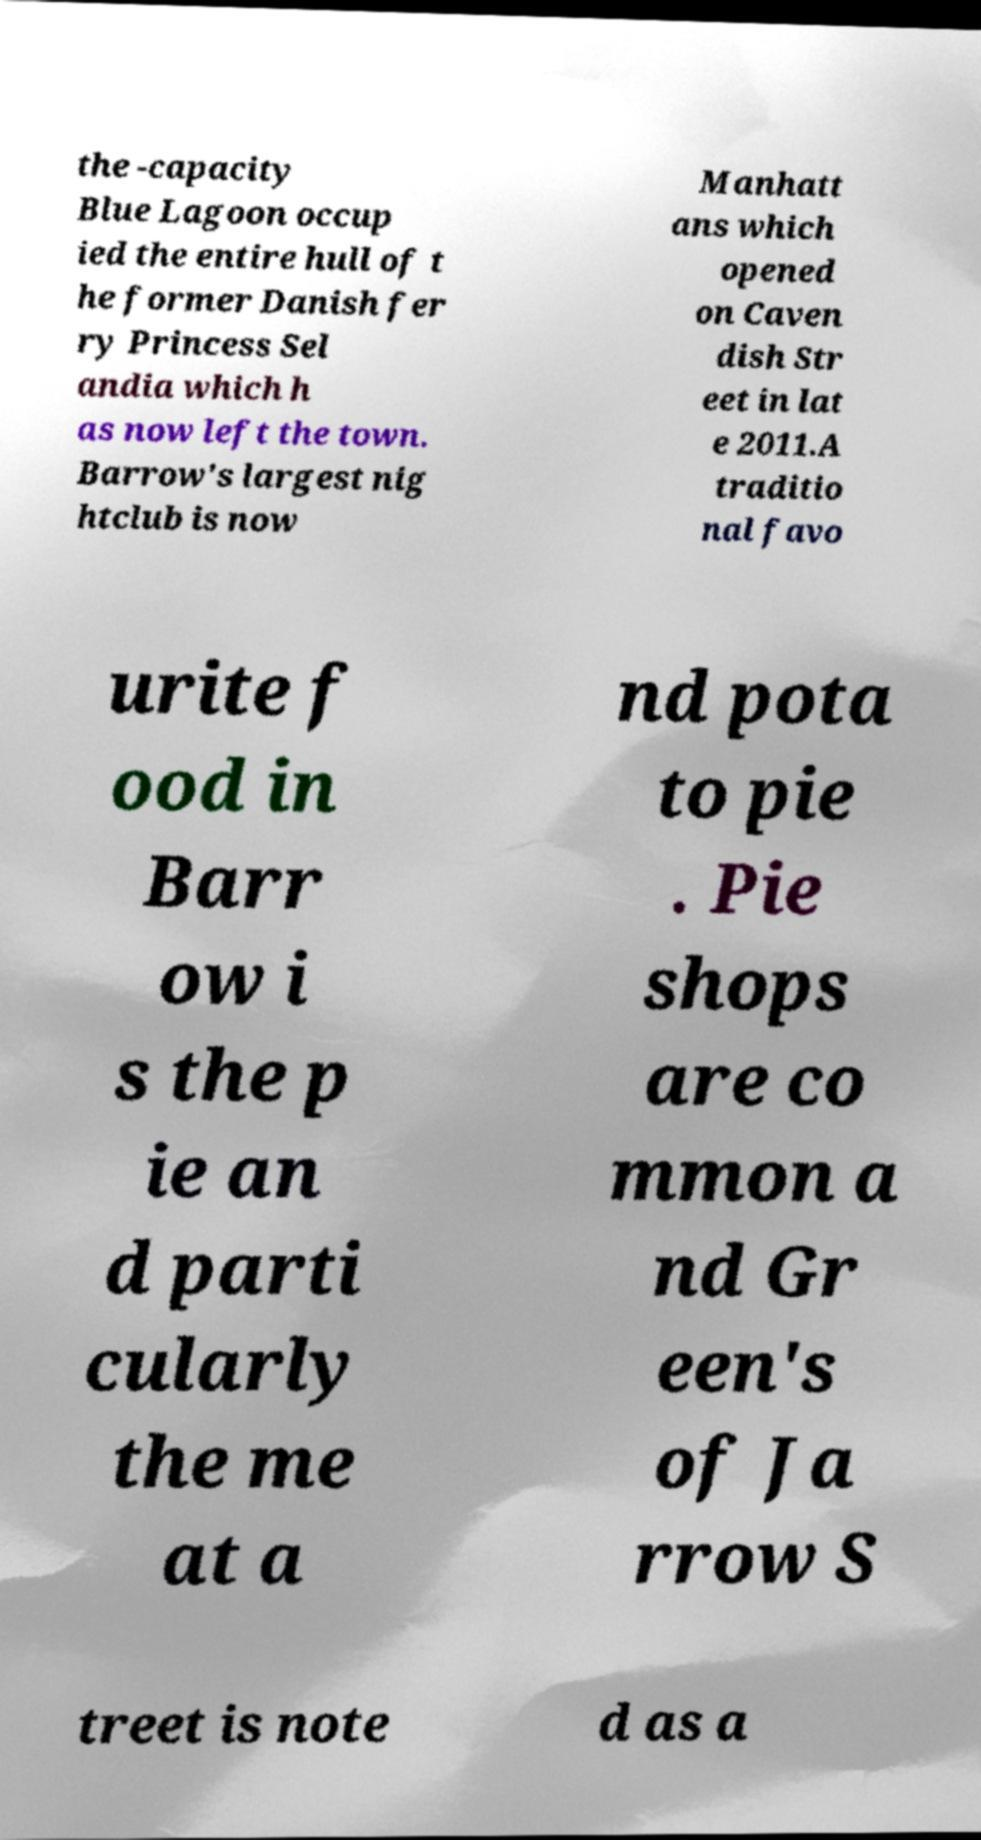For documentation purposes, I need the text within this image transcribed. Could you provide that? the -capacity Blue Lagoon occup ied the entire hull of t he former Danish fer ry Princess Sel andia which h as now left the town. Barrow's largest nig htclub is now Manhatt ans which opened on Caven dish Str eet in lat e 2011.A traditio nal favo urite f ood in Barr ow i s the p ie an d parti cularly the me at a nd pota to pie . Pie shops are co mmon a nd Gr een's of Ja rrow S treet is note d as a 